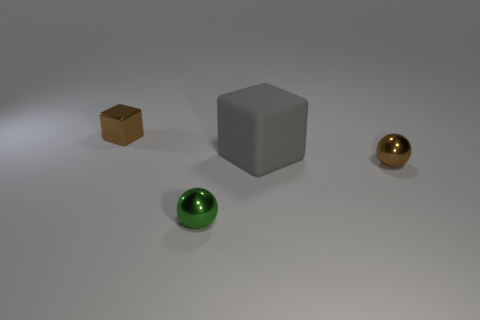Are there any other things that have the same size as the gray matte thing?
Offer a very short reply. No. What is the size of the metal thing that is the same color as the small metal block?
Your response must be concise. Small. What number of other things are the same shape as the large gray object?
Keep it short and to the point. 1. What is the material of the thing that is behind the brown sphere and right of the brown metallic block?
Make the answer very short. Rubber. The green thing is what size?
Give a very brief answer. Small. How many small metal things are right of the brown object to the left of the small brown metallic object that is on the right side of the tiny green metallic object?
Ensure brevity in your answer.  2. The brown object that is to the left of the ball that is to the left of the brown ball is what shape?
Your response must be concise. Cube. The block on the right side of the green shiny object is what color?
Make the answer very short. Gray. What material is the block to the right of the thing that is in front of the small brown metal object that is right of the large gray thing?
Provide a succinct answer. Rubber. There is a cube that is on the right side of the shiny sphere that is left of the large thing; what size is it?
Make the answer very short. Large. 